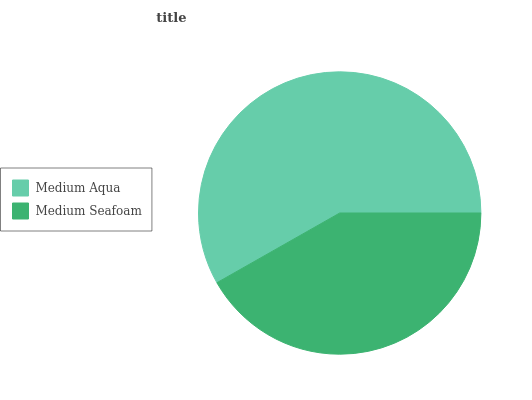Is Medium Seafoam the minimum?
Answer yes or no. Yes. Is Medium Aqua the maximum?
Answer yes or no. Yes. Is Medium Seafoam the maximum?
Answer yes or no. No. Is Medium Aqua greater than Medium Seafoam?
Answer yes or no. Yes. Is Medium Seafoam less than Medium Aqua?
Answer yes or no. Yes. Is Medium Seafoam greater than Medium Aqua?
Answer yes or no. No. Is Medium Aqua less than Medium Seafoam?
Answer yes or no. No. Is Medium Aqua the high median?
Answer yes or no. Yes. Is Medium Seafoam the low median?
Answer yes or no. Yes. Is Medium Seafoam the high median?
Answer yes or no. No. Is Medium Aqua the low median?
Answer yes or no. No. 